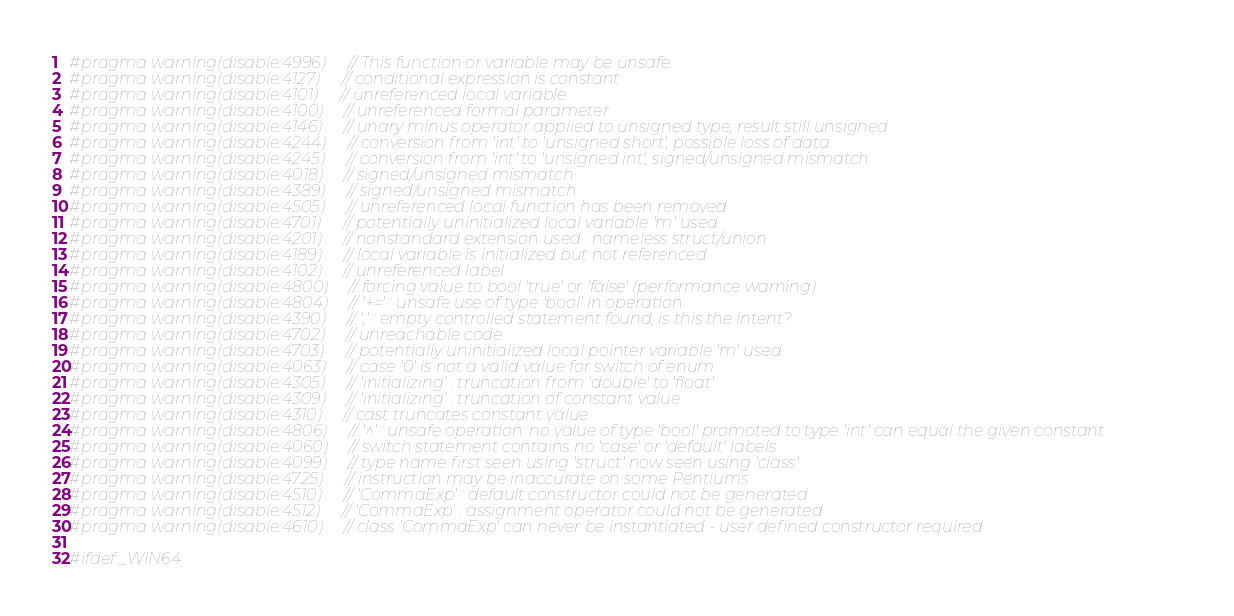<code> <loc_0><loc_0><loc_500><loc_500><_C_>#pragma warning(disable:4996) // This function or variable may be unsafe.
#pragma warning(disable:4127) // conditional expression is constant
#pragma warning(disable:4101) // unreferenced local variable
#pragma warning(disable:4100) // unreferenced formal parameter
#pragma warning(disable:4146) // unary minus operator applied to unsigned type, result still unsigned
#pragma warning(disable:4244) // conversion from 'int' to 'unsigned short', possible loss of data
#pragma warning(disable:4245) // conversion from 'int' to 'unsigned int', signed/unsigned mismatch
#pragma warning(disable:4018) // signed/unsigned mismatch
#pragma warning(disable:4389) // signed/unsigned mismatch
#pragma warning(disable:4505) // unreferenced local function has been removed
#pragma warning(disable:4701) // potentially uninitialized local variable 'm' used
#pragma warning(disable:4201) // nonstandard extension used : nameless struct/union
#pragma warning(disable:4189) // local variable is initialized but not referenced
#pragma warning(disable:4102) // unreferenced label
#pragma warning(disable:4800) // forcing value to bool 'true' or 'false' (performance warning)
#pragma warning(disable:4804) // '+=' : unsafe use of type 'bool' in operation
#pragma warning(disable:4390) // ';' : empty controlled statement found; is this the intent?
#pragma warning(disable:4702) // unreachable code
#pragma warning(disable:4703) // potentially uninitialized local pointer variable 'm' used
#pragma warning(disable:4063) // case '0' is not a valid value for switch of enum
#pragma warning(disable:4305) // 'initializing' : truncation from 'double' to 'float'
#pragma warning(disable:4309) // 'initializing' : truncation of constant value
#pragma warning(disable:4310) // cast truncates constant value
#pragma warning(disable:4806) // '^' : unsafe operation: no value of type 'bool' promoted to type 'int' can equal the given constant
#pragma warning(disable:4060) // switch statement contains no 'case' or 'default' labels
#pragma warning(disable:4099) // type name first seen using 'struct' now seen using 'class'
#pragma warning(disable:4725) // instruction may be inaccurate on some Pentiums
#pragma warning(disable:4510) // 'CommaExp' : default constructor could not be generated
#pragma warning(disable:4512) // 'CommaExp' : assignment operator could not be generated
#pragma warning(disable:4610) // class 'CommaExp' can never be instantiated - user defined constructor required

#ifdef _WIN64</code> 